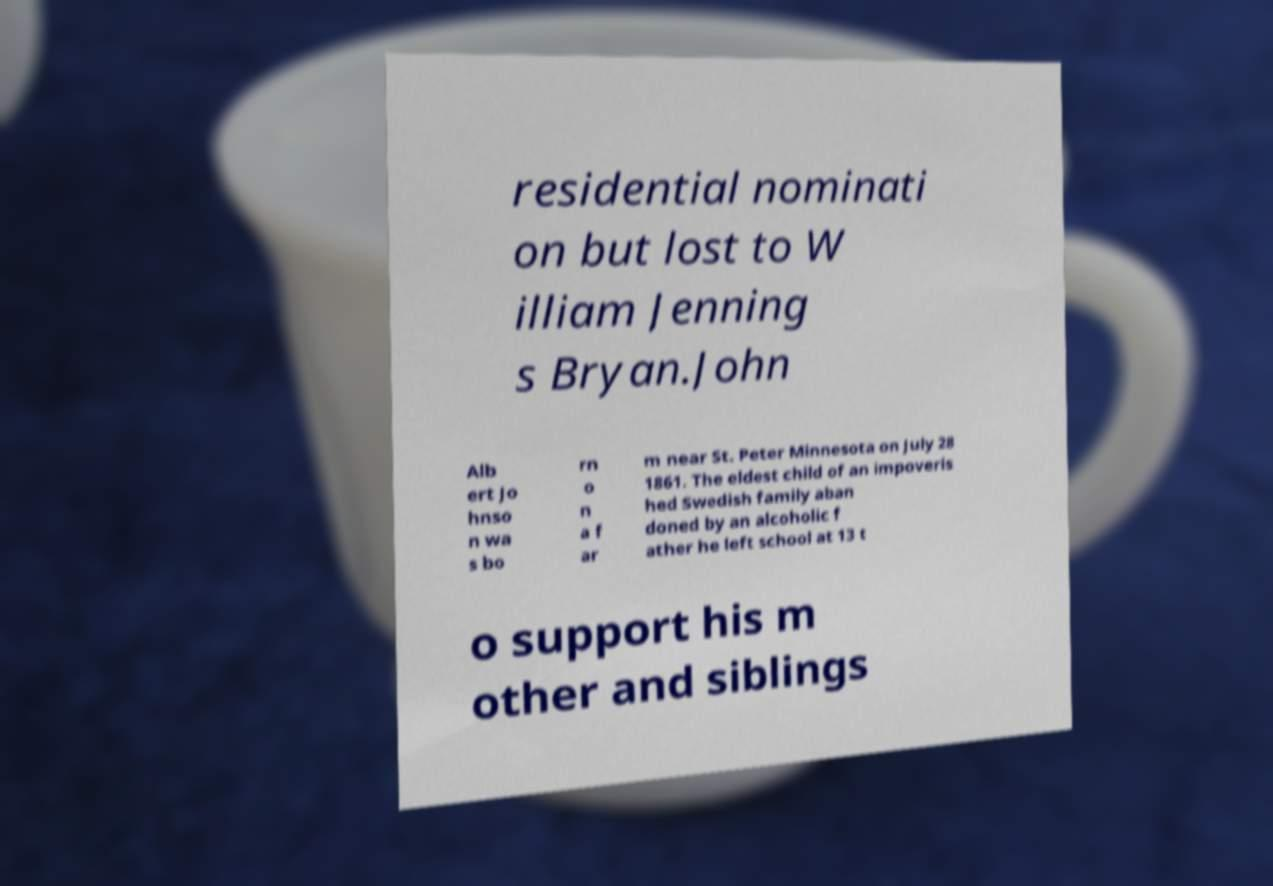There's text embedded in this image that I need extracted. Can you transcribe it verbatim? residential nominati on but lost to W illiam Jenning s Bryan.John Alb ert Jo hnso n wa s bo rn o n a f ar m near St. Peter Minnesota on July 28 1861. The eldest child of an impoveris hed Swedish family aban doned by an alcoholic f ather he left school at 13 t o support his m other and siblings 